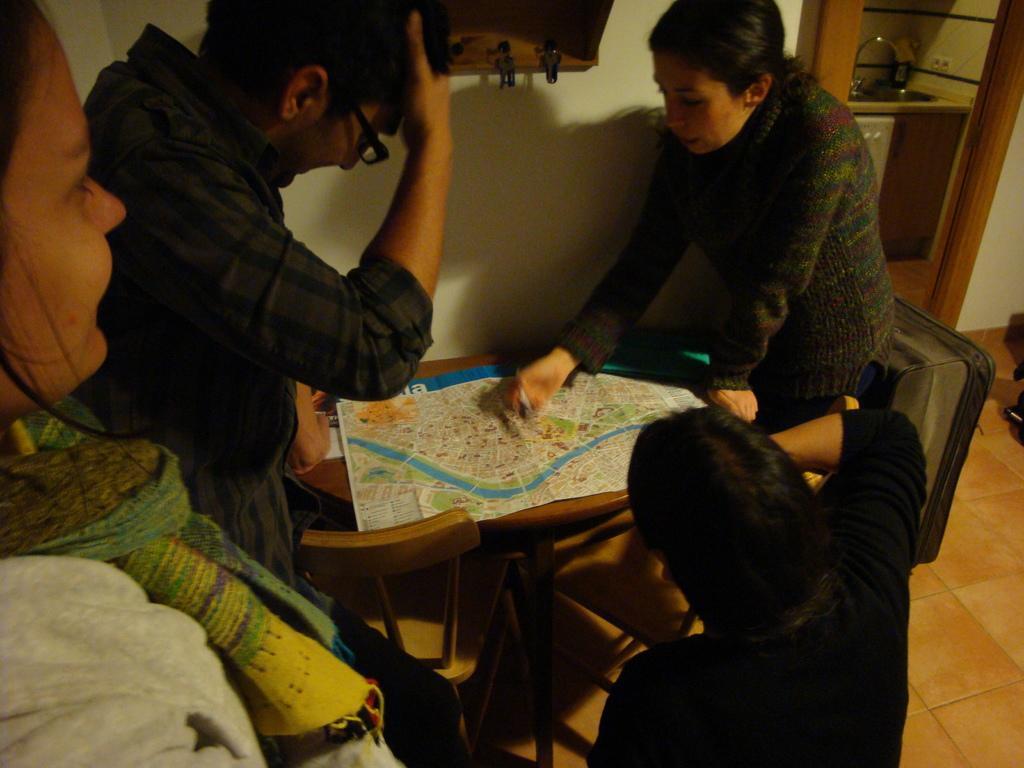Can you describe this image briefly? The image is clicked inside the house. There are four people in the image. They are seeing a chart which is placed on a table. To the right there is a door of the kitchen. At the bottom there is a floor with brown tiles. 